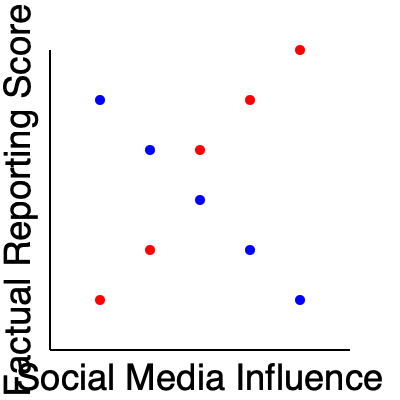As a news anchor discussing misinformation, what potential issue can you identify in this scatter plot depicting the relationship between social media influence and factual reporting scores? To evaluate this scatter plot, we need to consider several factors:

1. Data representation: The scatter plot shows two distinct trends (red and blue points) for the same variables.

2. Correlation analysis:
   - Red points: Show a negative correlation between social media influence and factual reporting scores.
   - Blue points: Show a positive correlation between the same variables.

3. Conflicting trends: The presence of two contradictory trends in the same dataset is highly unusual and likely indicates a problem with data collection, analysis, or representation.

4. Implications for misinformation: This graph could be misleading as it presents two opposing narratives:
   a) Higher social media influence correlates with lower factual reporting (red points)
   b) Higher social media influence correlates with higher factual reporting (blue points)

5. Potential causes:
   - Data manipulation: Intentional alteration to support different narratives
   - Sampling bias: Different data sources or time periods combined without proper context
   - Confounding variables: Unaccounted factors influencing the relationship

6. Impact on public perception: Such a graph could be used to support contradictory claims about the relationship between social media influence and factual reporting, potentially contributing to misinformation.

The main issue here is the presence of conflicting trends in the same dataset, which raises questions about the data's validity and potential for misinterpretation or misuse in public discourse.
Answer: Conflicting trends in the same dataset, indicating potential data manipulation or misrepresentation 